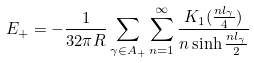<formula> <loc_0><loc_0><loc_500><loc_500>E _ { + } = - \frac { 1 } { 3 2 \pi R } \sum _ { \gamma \in A _ { + } } \sum _ { n = 1 } ^ { \infty } \frac { K _ { 1 } ( \frac { n l _ { \gamma } } { 4 } ) } { n \sinh \frac { n l _ { \gamma } } { 2 } }</formula> 